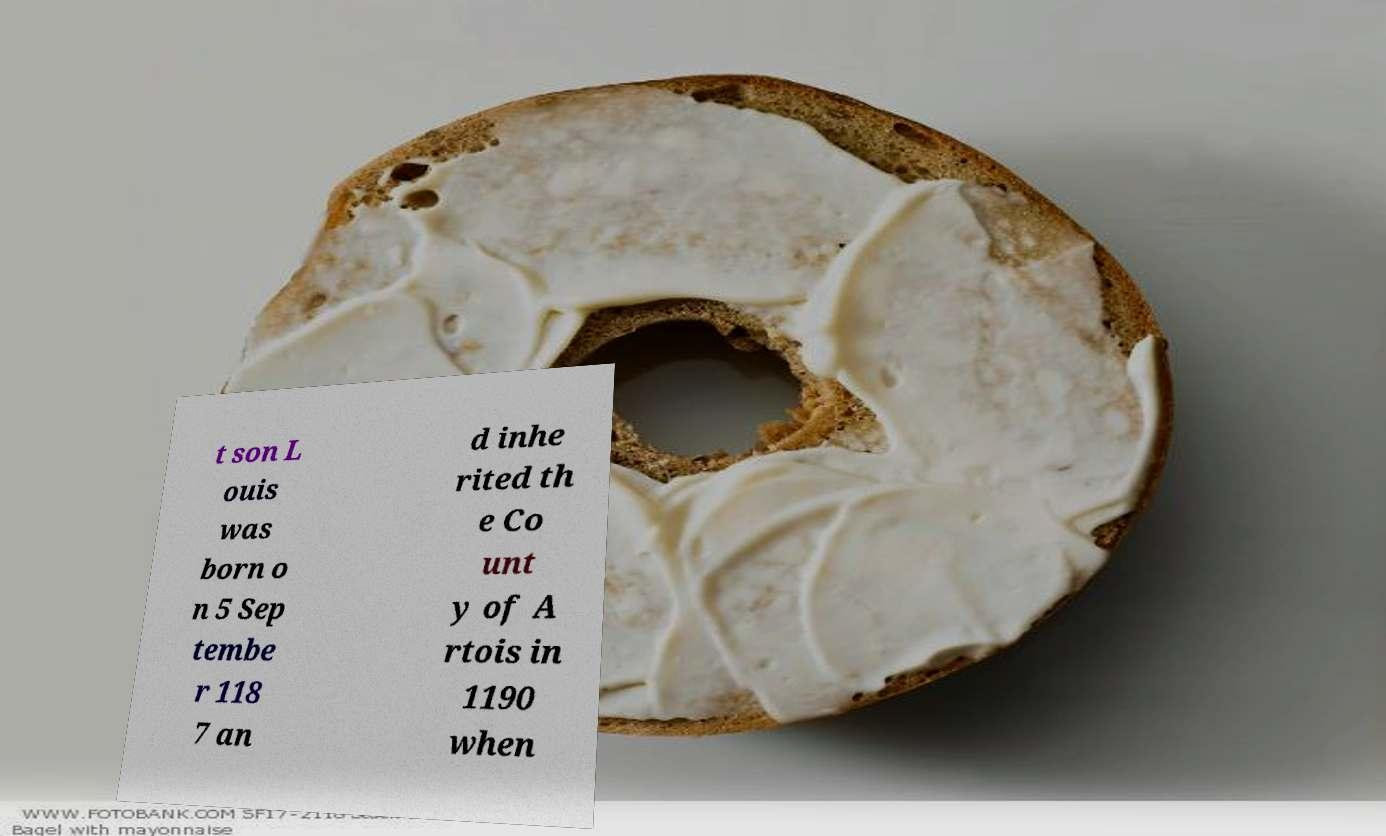Could you assist in decoding the text presented in this image and type it out clearly? t son L ouis was born o n 5 Sep tembe r 118 7 an d inhe rited th e Co unt y of A rtois in 1190 when 